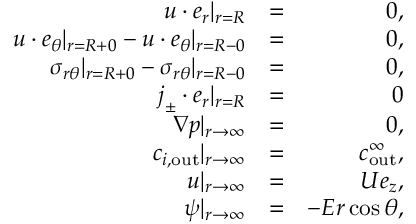Convert formula to latex. <formula><loc_0><loc_0><loc_500><loc_500>\begin{array} { r l r } { u \cdot e _ { r } | _ { r = R } } & { = } & { 0 , } \\ { u \cdot e _ { \theta } | _ { r = R + 0 } - u \cdot e _ { \theta } | _ { r = R - 0 } } & { = } & { 0 , } \\ { \sigma _ { r \theta } | _ { r = R + 0 } - \sigma _ { r \theta } | _ { r = R - 0 } } & { = } & { 0 , } \\ { j _ { \pm } \cdot e _ { r } | _ { r = R } } & { = } & { 0 } \\ { \nabla p | _ { r \to \infty } } & { = } & { 0 , } \\ { c _ { i , o u t } | _ { r \to \infty } } & { = } & { c _ { o u t } ^ { \infty } , } \\ { u | _ { r \to \infty } } & { = } & { U e _ { z } , } \\ { \psi | _ { r \to \infty } } & { = } & { - E r \cos \theta , } \end{array}</formula> 